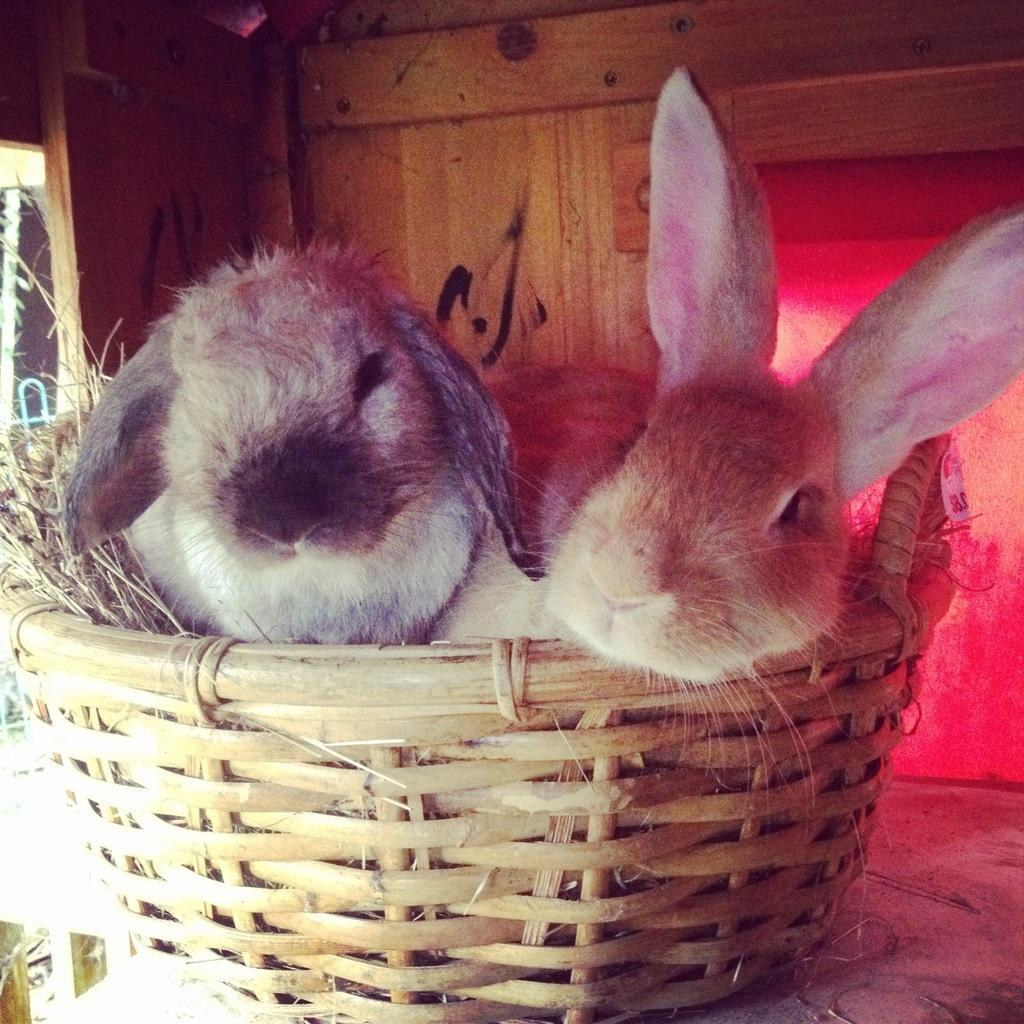How many rabbits are in the image? There are two rabbits in the image. Where are the rabbits located? The rabbits are in a basket. What is in the basket with the rabbits? There is grass in the basket. What can be seen in the background of the image? There is a wooden wall and a red curtain in the background of the image. What type of weather can be seen in the image? The image does not depict any weather conditions; it is an indoor scene with rabbits in a basket. 